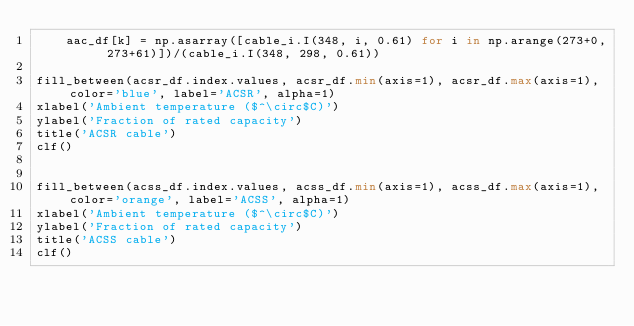Convert code to text. <code><loc_0><loc_0><loc_500><loc_500><_Python_>    aac_df[k] = np.asarray([cable_i.I(348, i, 0.61) for i in np.arange(273+0, 273+61)])/(cable_i.I(348, 298, 0.61))

fill_between(acsr_df.index.values, acsr_df.min(axis=1), acsr_df.max(axis=1), color='blue', label='ACSR', alpha=1)
xlabel('Ambient temperature ($^\circ$C)')
ylabel('Fraction of rated capacity')
title('ACSR cable')
clf()


fill_between(acss_df.index.values, acss_df.min(axis=1), acss_df.max(axis=1), color='orange', label='ACSS', alpha=1)
xlabel('Ambient temperature ($^\circ$C)')
ylabel('Fraction of rated capacity')
title('ACSS cable')
clf()
</code> 